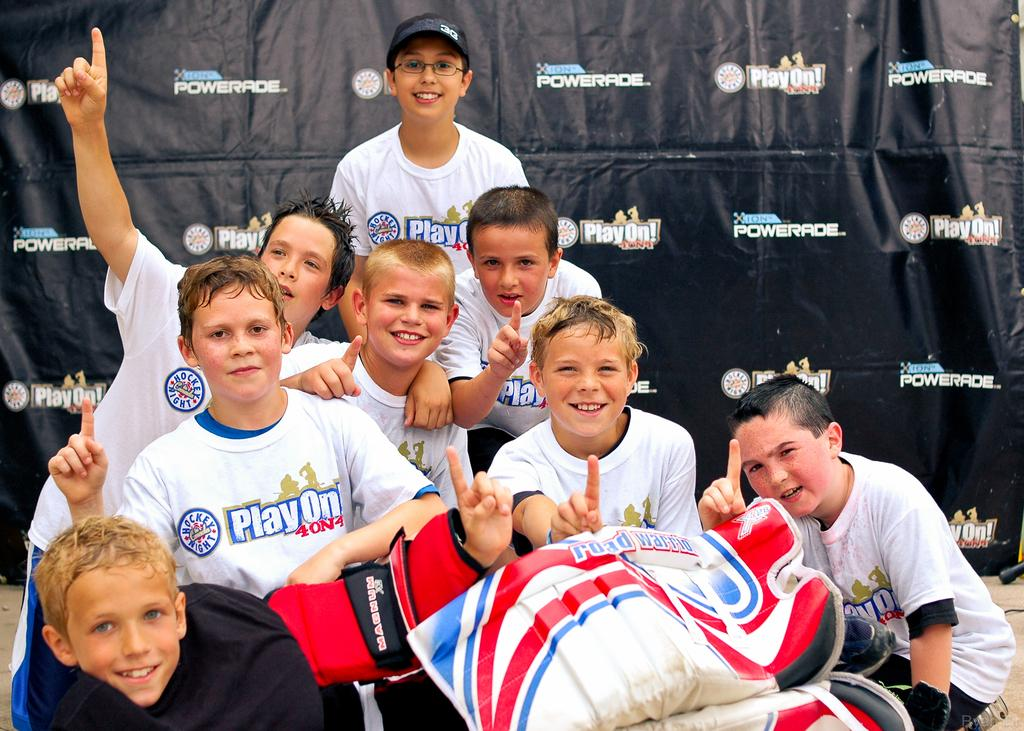<image>
Describe the image concisely. Children wearing white shirts that say Playon behind a black banner. 